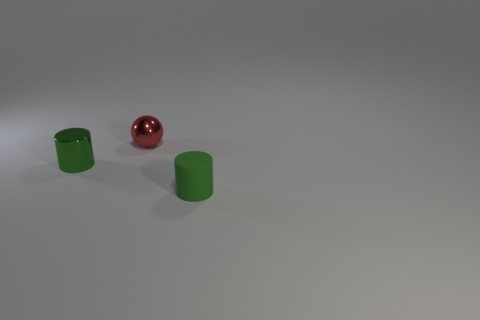What size is the object that is both in front of the tiny ball and behind the green rubber cylinder?
Offer a terse response. Small. There is a small cylinder behind the tiny rubber cylinder; is it the same color as the tiny cylinder that is on the right side of the green metallic thing?
Your answer should be very brief. Yes. What size is the cylinder that is the same color as the tiny matte object?
Offer a terse response. Small. There is a green cylinder that is on the right side of the small cylinder that is on the left side of the small metal sphere; is there a small green cylinder behind it?
Your answer should be compact. Yes. There is a green metallic thing; what number of small metal cylinders are to the left of it?
Offer a very short reply. 0. What material is the tiny cylinder that is the same color as the small matte thing?
Keep it short and to the point. Metal. What number of small things are either green objects or rubber spheres?
Make the answer very short. 2. What is the shape of the metal thing that is behind the tiny green shiny cylinder?
Ensure brevity in your answer.  Sphere. Are there any shiny things of the same color as the matte cylinder?
Keep it short and to the point. Yes. There is a green thing on the left side of the tiny red shiny sphere; is it the same size as the green thing that is in front of the small green metal cylinder?
Give a very brief answer. Yes. 